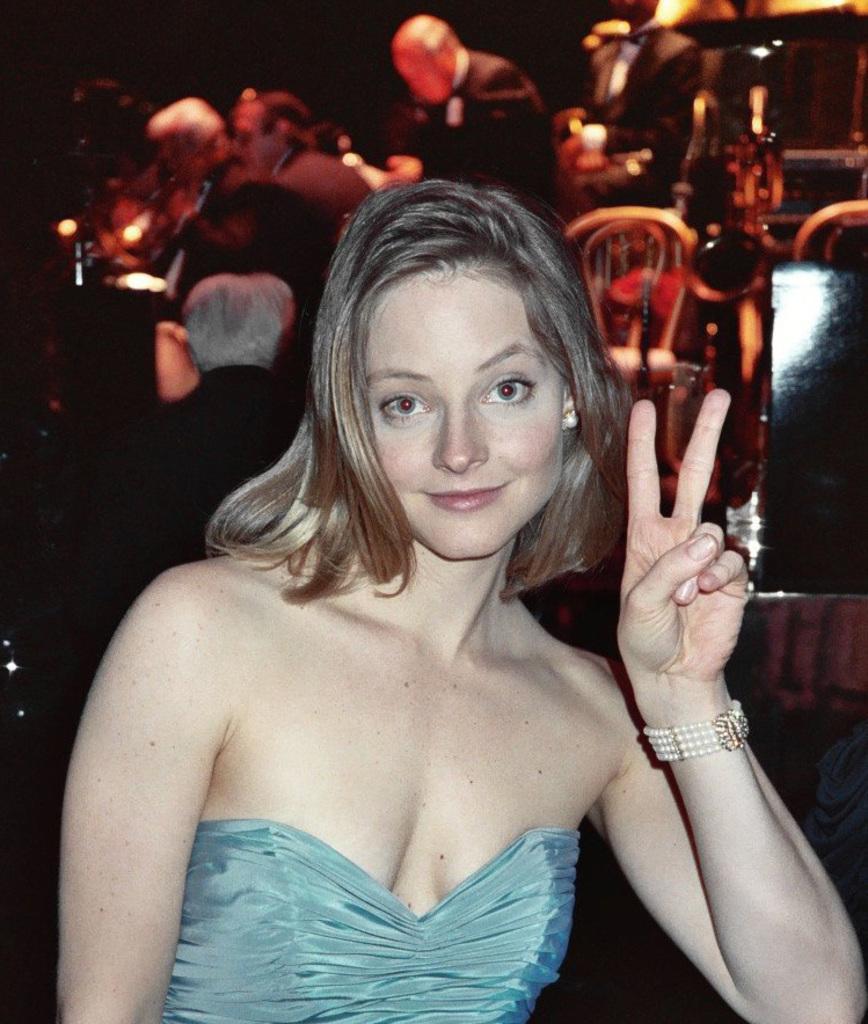Describe this image in one or two sentences. In the picture we can see a woman standing near the table, she is in a blue dress and showing her two fingers and behind her we can see a few people are sitting on the chairs near the table. 